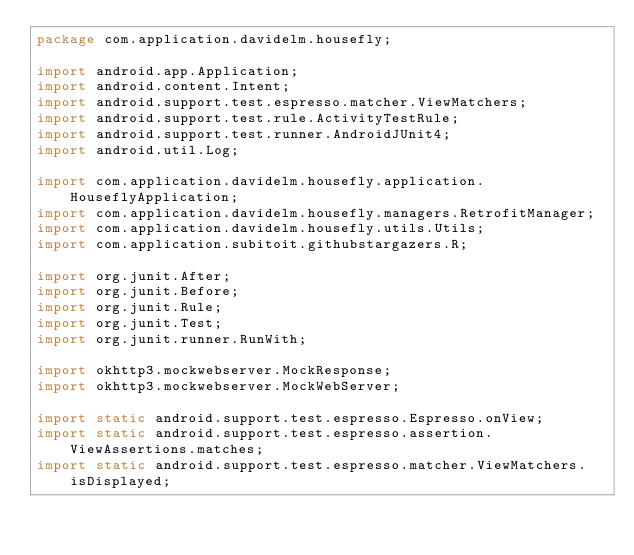Convert code to text. <code><loc_0><loc_0><loc_500><loc_500><_Java_>package com.application.davidelm.housefly;

import android.app.Application;
import android.content.Intent;
import android.support.test.espresso.matcher.ViewMatchers;
import android.support.test.rule.ActivityTestRule;
import android.support.test.runner.AndroidJUnit4;
import android.util.Log;

import com.application.davidelm.housefly.application.HouseflyApplication;
import com.application.davidelm.housefly.managers.RetrofitManager;
import com.application.davidelm.housefly.utils.Utils;
import com.application.subitoit.githubstargazers.R;

import org.junit.After;
import org.junit.Before;
import org.junit.Rule;
import org.junit.Test;
import org.junit.runner.RunWith;

import okhttp3.mockwebserver.MockResponse;
import okhttp3.mockwebserver.MockWebServer;

import static android.support.test.espresso.Espresso.onView;
import static android.support.test.espresso.assertion.ViewAssertions.matches;
import static android.support.test.espresso.matcher.ViewMatchers.isDisplayed;</code> 